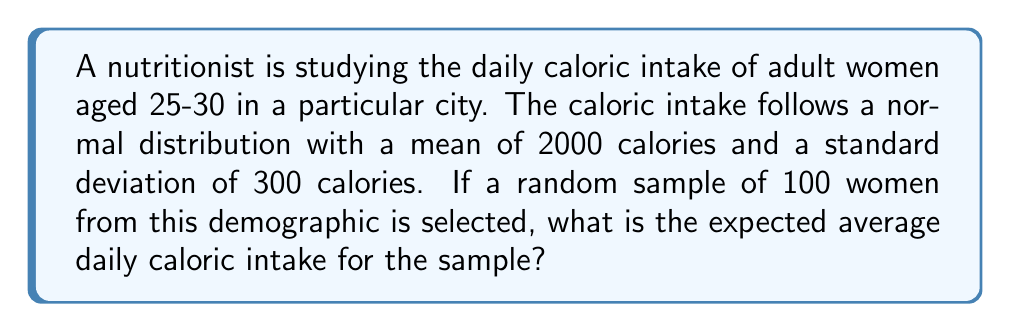Teach me how to tackle this problem. Let's approach this step-by-step:

1) We are given that the daily caloric intake for individual women follows a normal distribution with:
   $\mu = 2000$ calories (population mean)
   $\sigma = 300$ calories (population standard deviation)

2) We want to find the expected value of the sample mean for a sample of 100 women.

3) The key concept here is the Central Limit Theorem, which states that the sampling distribution of the sample mean approaches a normal distribution as the sample size increases, regardless of the shape of the population distribution.

4) For the sampling distribution of the sample mean:
   - The expected value is equal to the population mean
   - The standard error (standard deviation of the sampling distribution) is given by:
     $SE = \frac{\sigma}{\sqrt{n}}$

   Where $n$ is the sample size.

5) In this case:
   $n = 100$
   $SE = \frac{300}{\sqrt{100}} = \frac{300}{10} = 30$

6) However, we're only asked for the expected value of the sample mean, which is equal to the population mean.

7) Therefore, the expected average daily caloric intake for the sample is 2000 calories.
Answer: 2000 calories 